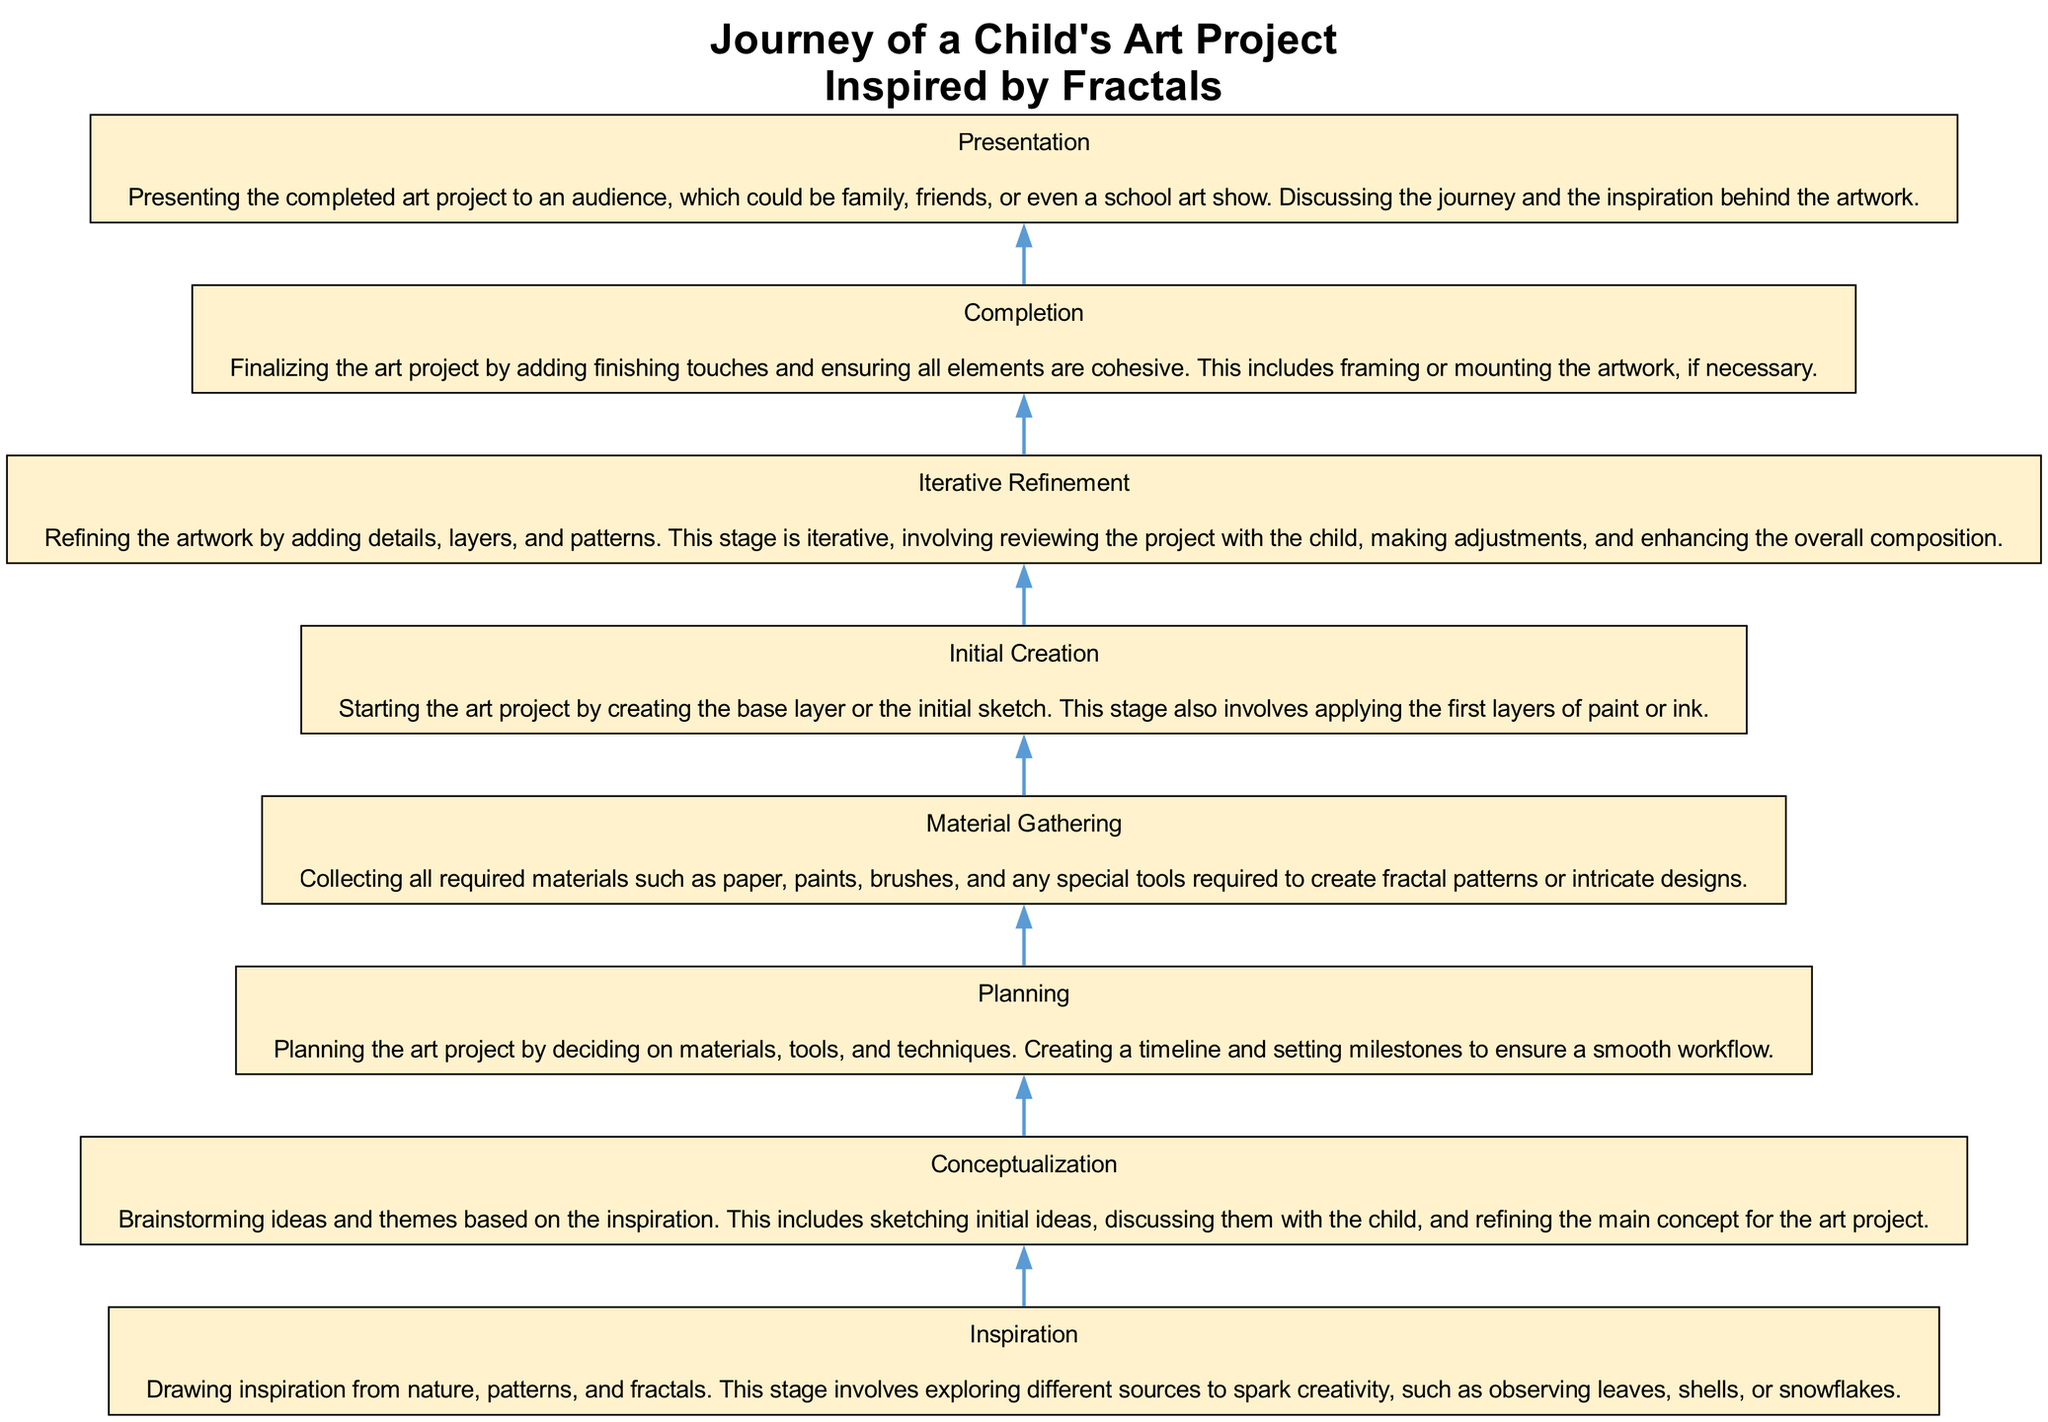What is the first stage of the child's art project? The first stage, as indicated at the bottom of the diagram, is "Inspiration".
Answer: Inspiration How many stages are included in the art project journey? By counting the nodes in the diagram, there are a total of eight stages from "Inspiration" to "Presentation".
Answer: Eight What stage comes immediately after "Material Gathering"? The stage that follows "Material Gathering" is "Initial Creation", as shown by the upward flow of the diagram.
Answer: Initial Creation Which stage involves refining the artwork? The stage named "Iterative Refinement" is specifically dedicated to refining the artwork, as indicated in the diagram.
Answer: Iterative Refinement What is the relationship between "Conceptualization" and "Planning"? "Conceptualization" leads into "Planning", indicating that conceptual ideas help inform the planning process.
Answer: Conceptualization leads to Planning In which stage does the artwork get presented? The final stage called "Presentation" is where the completed artwork is presented to an audience.
Answer: Presentation After "Initial Creation", what is the next step in the process? The next step in the process after "Initial Creation" is "Iterative Refinement", which builds upon the initial work.
Answer: Iterative Refinement What is the main activity during the "Planning" stage? The main activity during the "Planning" stage involves deciding on materials, tools, and creating a timeline for the project.
Answer: Deciding on materials, tools, and timeline In what stage is the theme based on inspiration brainstormed? The theme is brainstormed during the "Conceptualization" stage of the project, according to the diagram.
Answer: Conceptualization 